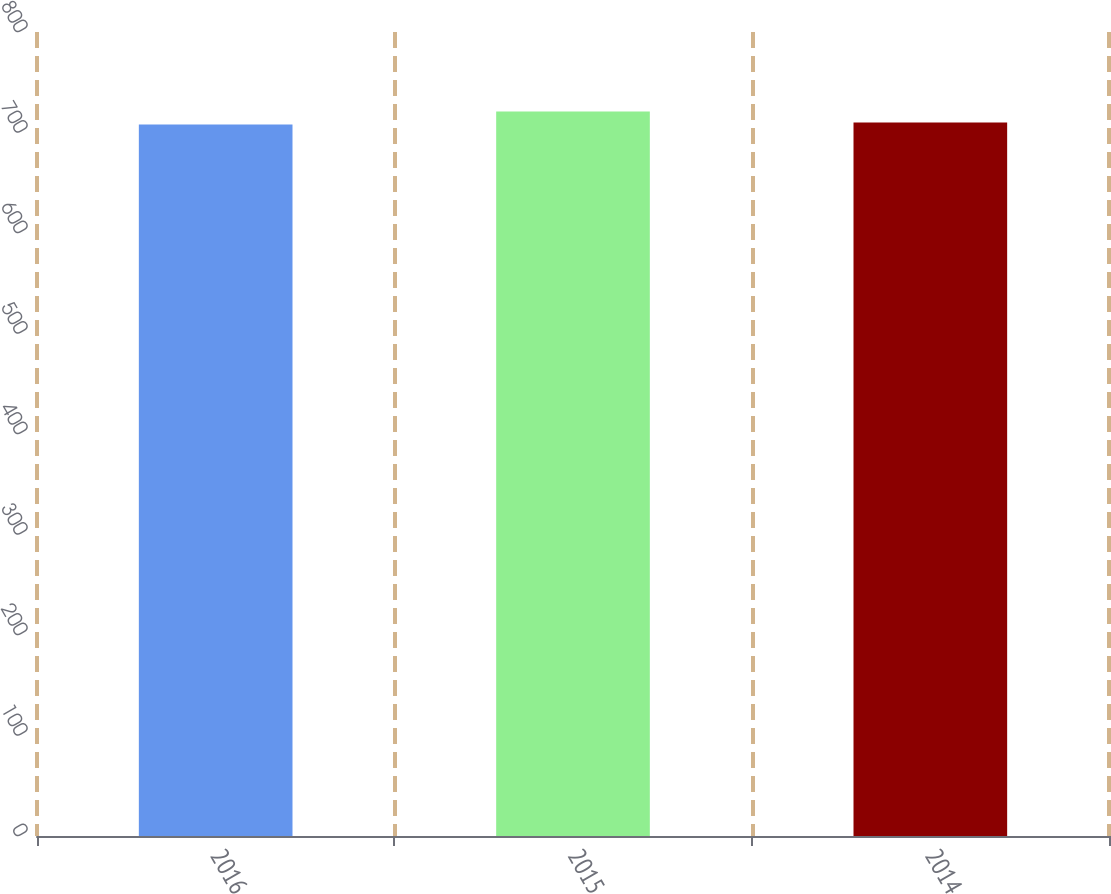Convert chart to OTSL. <chart><loc_0><loc_0><loc_500><loc_500><bar_chart><fcel>2016<fcel>2015<fcel>2014<nl><fcel>708<fcel>721<fcel>710<nl></chart> 